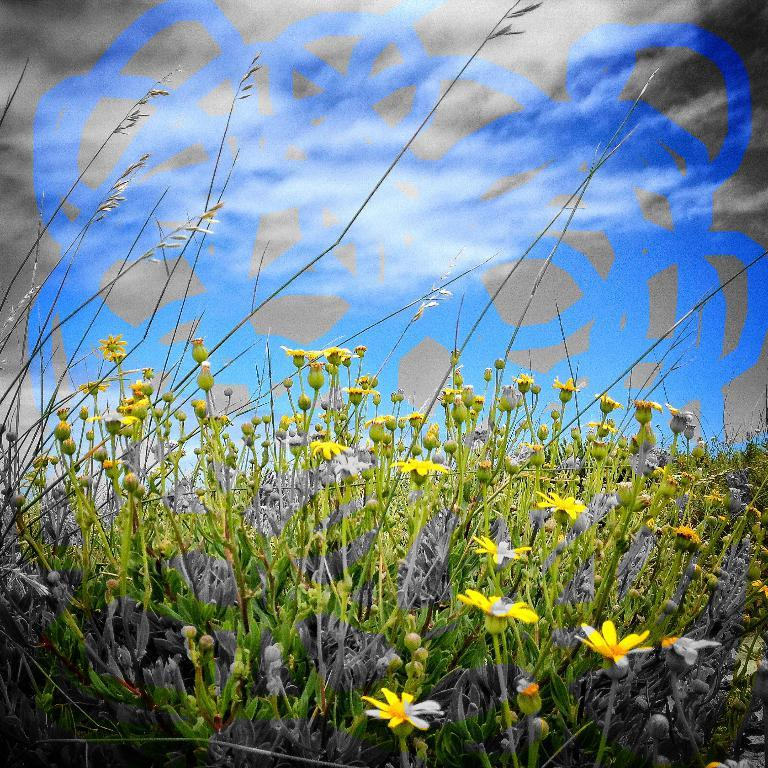What type of living organisms can be seen in the image? Plants can be seen in the image. What stage of growth are the plants in? The plants have flowers and buds, indicating that they are in a mature stage of growth. What is visible in the background of the image? There is a poster in the background of the image. What is depicted on the poster? The poster contains a painting. How many sacks are being used to support the plants in the image? There are no sacks present in the image; the plants are supported by soil and their own stems. What type of tent can be seen in the background of the image? There is no tent present in the image; the background features a poster with a painting. 